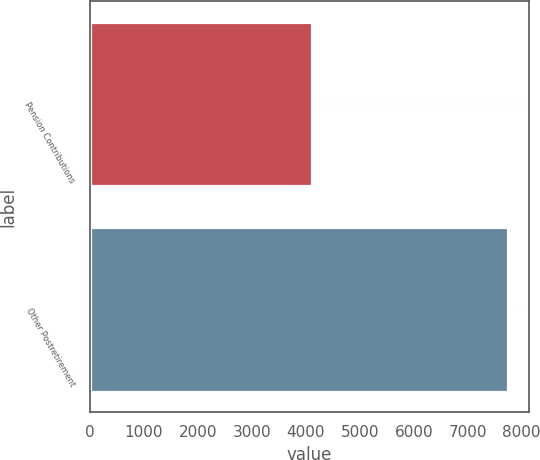<chart> <loc_0><loc_0><loc_500><loc_500><bar_chart><fcel>Pension Contributions<fcel>Other Postretirement<nl><fcel>4118<fcel>7745<nl></chart> 